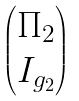<formula> <loc_0><loc_0><loc_500><loc_500>\begin{pmatrix} \Pi _ { 2 } \\ I _ { g _ { 2 } } \end{pmatrix}</formula> 